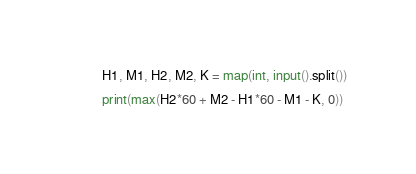Convert code to text. <code><loc_0><loc_0><loc_500><loc_500><_Python_>H1, M1, H2, M2, K = map(int, input().split())

print(max(H2*60 + M2 - H1*60 - M1 - K, 0))</code> 